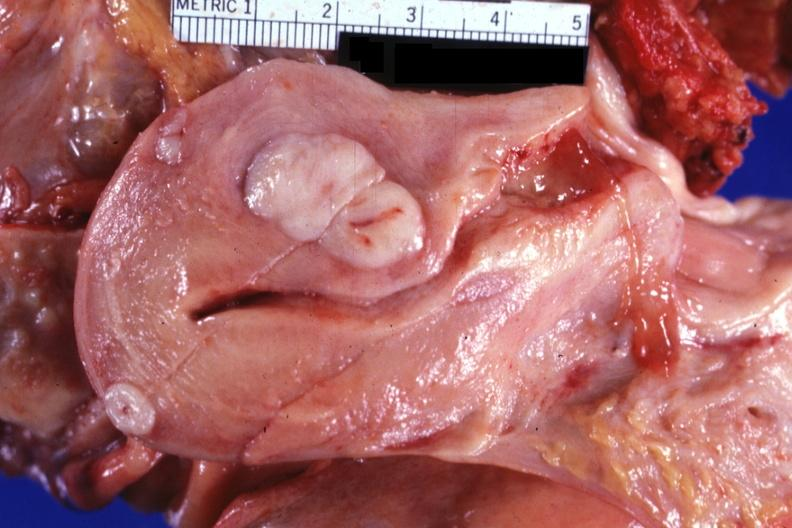what does this image show?
Answer the question using a single word or phrase. Sectioned uterus shown close-up with typical small myomas very good 